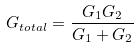Convert formula to latex. <formula><loc_0><loc_0><loc_500><loc_500>G _ { t o t a l } = \frac { G _ { 1 } G _ { 2 } } { G _ { 1 } + G _ { 2 } }</formula> 